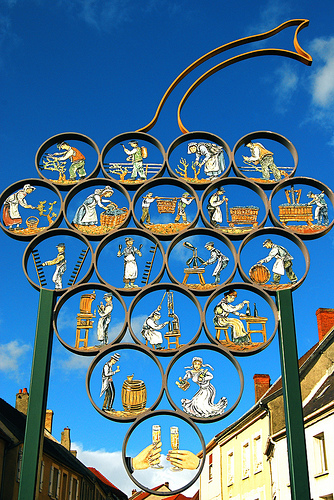<image>
Can you confirm if the woman is in the grapes? Yes. The woman is contained within or inside the grapes, showing a containment relationship. Is the champagne in the grapes? Yes. The champagne is contained within or inside the grapes, showing a containment relationship. 